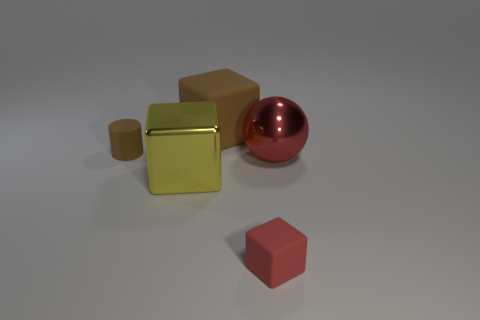Add 1 matte balls. How many objects exist? 6 Subtract all cylinders. How many objects are left? 4 Add 5 large spheres. How many large spheres are left? 6 Add 4 large yellow shiny things. How many large yellow shiny things exist? 5 Subtract 1 red blocks. How many objects are left? 4 Subtract all big red spheres. Subtract all tiny matte blocks. How many objects are left? 3 